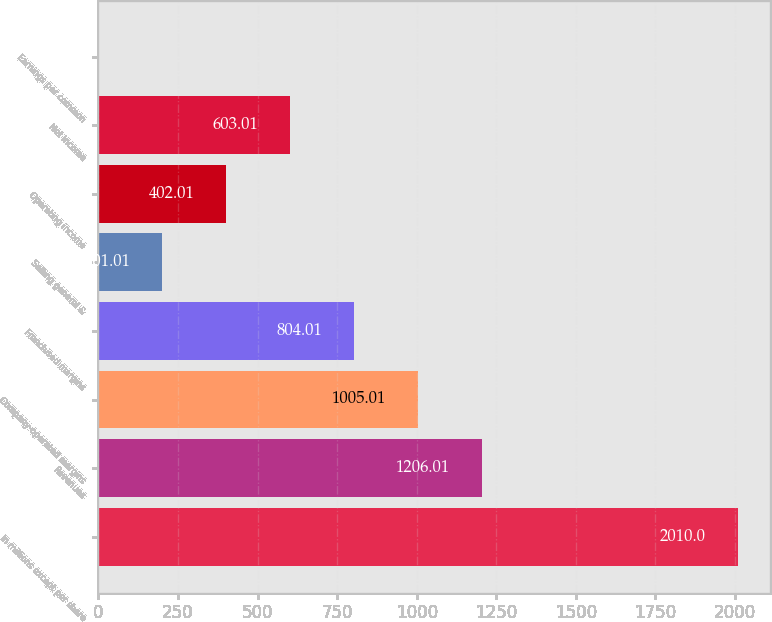<chart> <loc_0><loc_0><loc_500><loc_500><bar_chart><fcel>In millions except per share<fcel>Revenues<fcel>Company-operated margins<fcel>Franchised margins<fcel>Selling general &<fcel>Operating income<fcel>Net income<fcel>Earnings per common<nl><fcel>2010<fcel>1206.01<fcel>1005.01<fcel>804.01<fcel>201.01<fcel>402.01<fcel>603.01<fcel>0.01<nl></chart> 